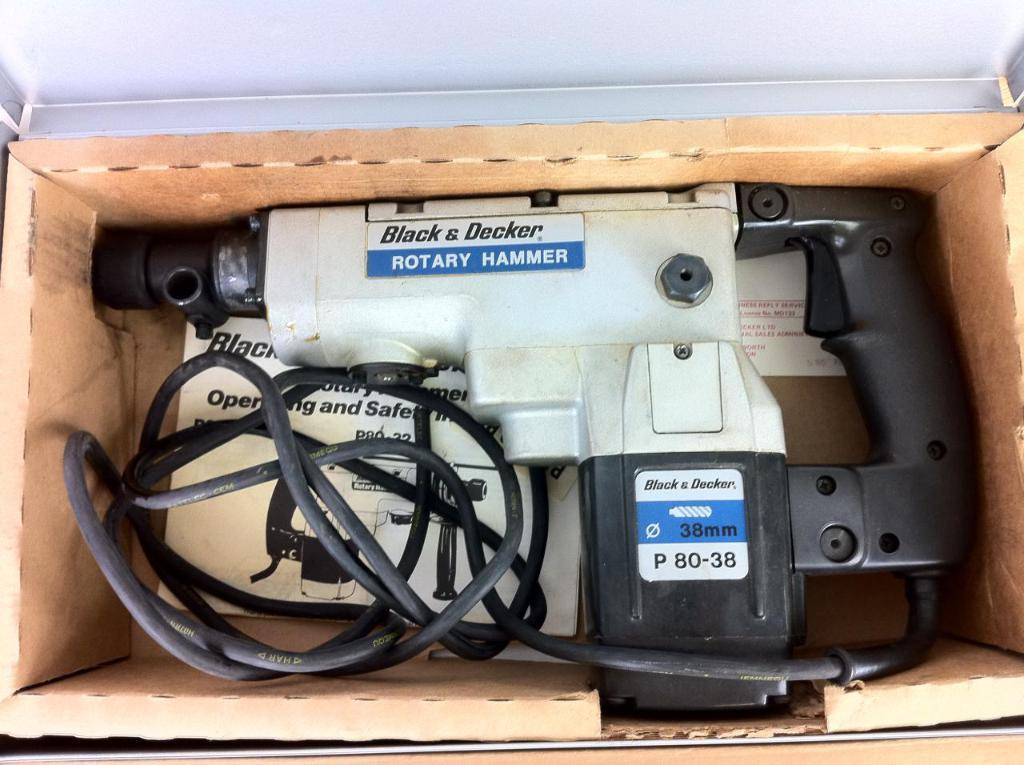What is the main subject in the image? There is a machine in the image. What colors are used for the machine? The machine is in white and black color. Where is the machine located? The machine is inside a box. What can be seen in the background of the image? The background of the image is a white wall. How many snakes are coiled around the machine in the image? There are no snakes present in the image; the machine is inside a box with a white and black color scheme and a white wall background. 